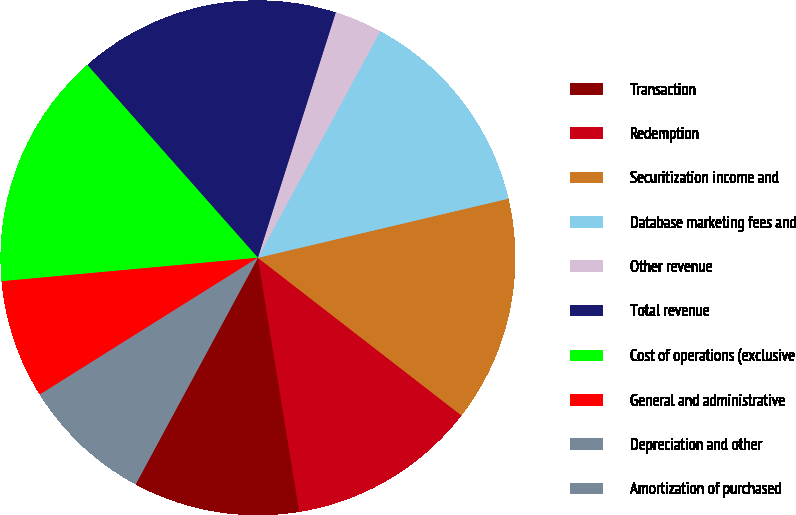<chart> <loc_0><loc_0><loc_500><loc_500><pie_chart><fcel>Transaction<fcel>Redemption<fcel>Securitization income and<fcel>Database marketing fees and<fcel>Other revenue<fcel>Total revenue<fcel>Cost of operations (exclusive<fcel>General and administrative<fcel>Depreciation and other<fcel>Amortization of purchased<nl><fcel>10.45%<fcel>11.94%<fcel>14.18%<fcel>13.43%<fcel>2.99%<fcel>16.42%<fcel>14.93%<fcel>7.46%<fcel>3.73%<fcel>4.48%<nl></chart> 